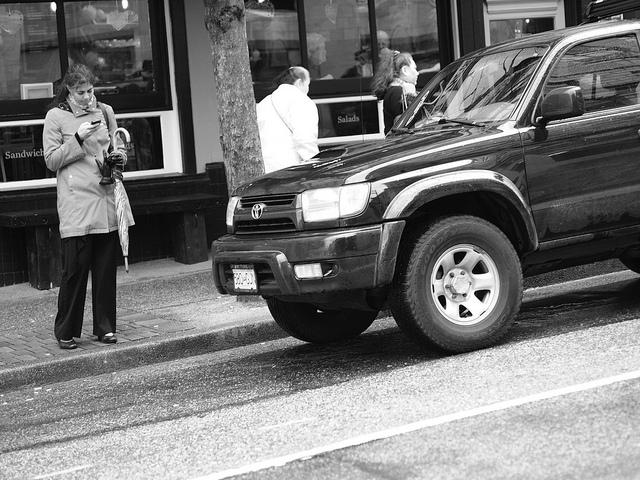Which automotive manufacturer made the jeep? Please explain your reasoning. toyota. The toyota logo is visible from the front of the automobile. 